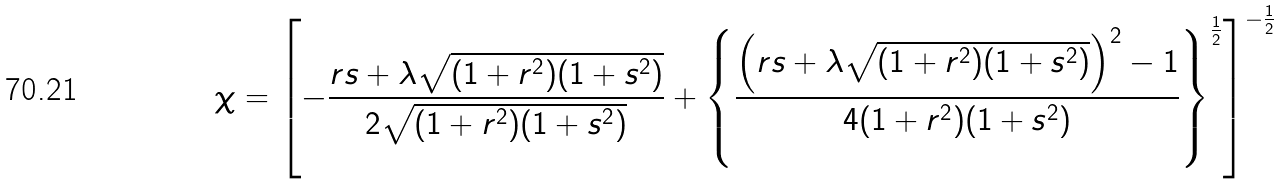<formula> <loc_0><loc_0><loc_500><loc_500>\chi = \left [ - \frac { r s + \lambda \sqrt { ( 1 + r ^ { 2 } ) ( 1 + s ^ { 2 } ) } } { 2 \sqrt { ( 1 + r ^ { 2 } ) ( 1 + s ^ { 2 } ) } } + \left \{ \frac { \left ( r s + \lambda \sqrt { ( 1 + r ^ { 2 } ) ( 1 + s ^ { 2 } ) } \right ) ^ { 2 } - 1 } { 4 ( 1 + r ^ { 2 } ) ( 1 + s ^ { 2 } ) } \right \} ^ { \frac { 1 } { 2 } } \right ] ^ { - \frac { 1 } { 2 } }</formula> 